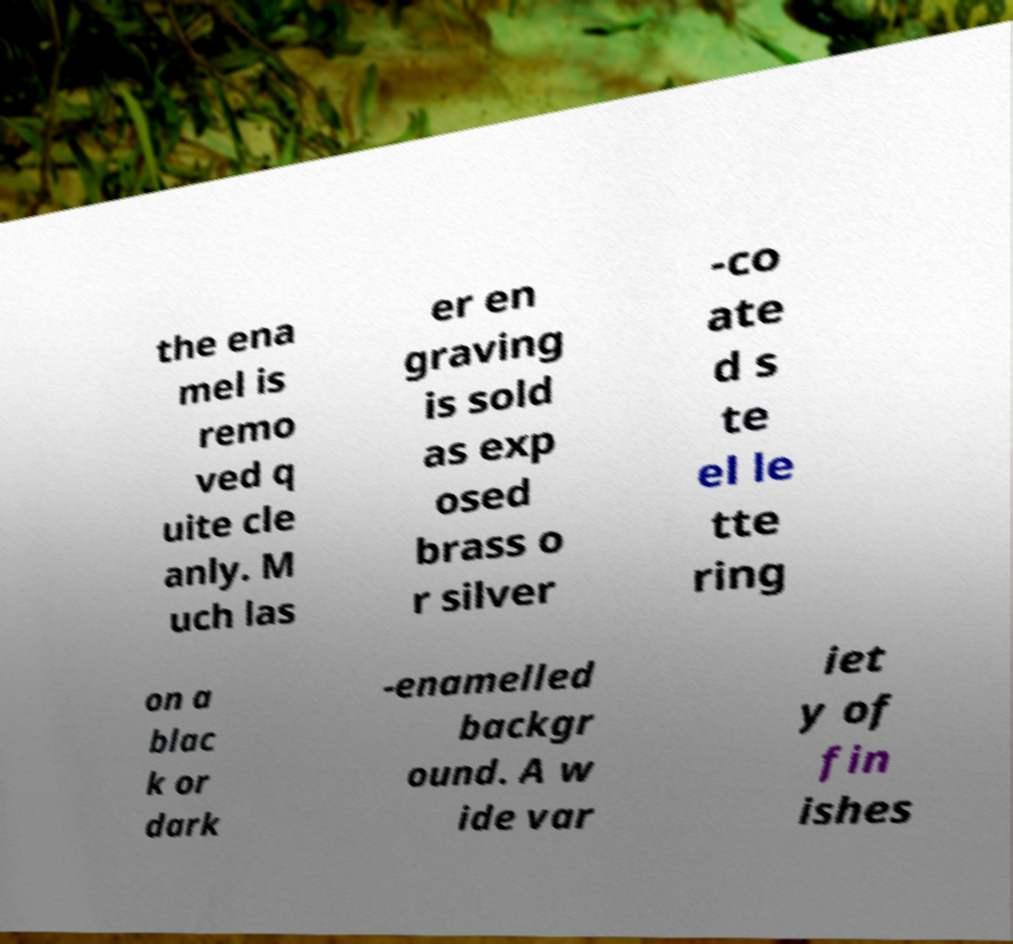Could you extract and type out the text from this image? the ena mel is remo ved q uite cle anly. M uch las er en graving is sold as exp osed brass o r silver -co ate d s te el le tte ring on a blac k or dark -enamelled backgr ound. A w ide var iet y of fin ishes 